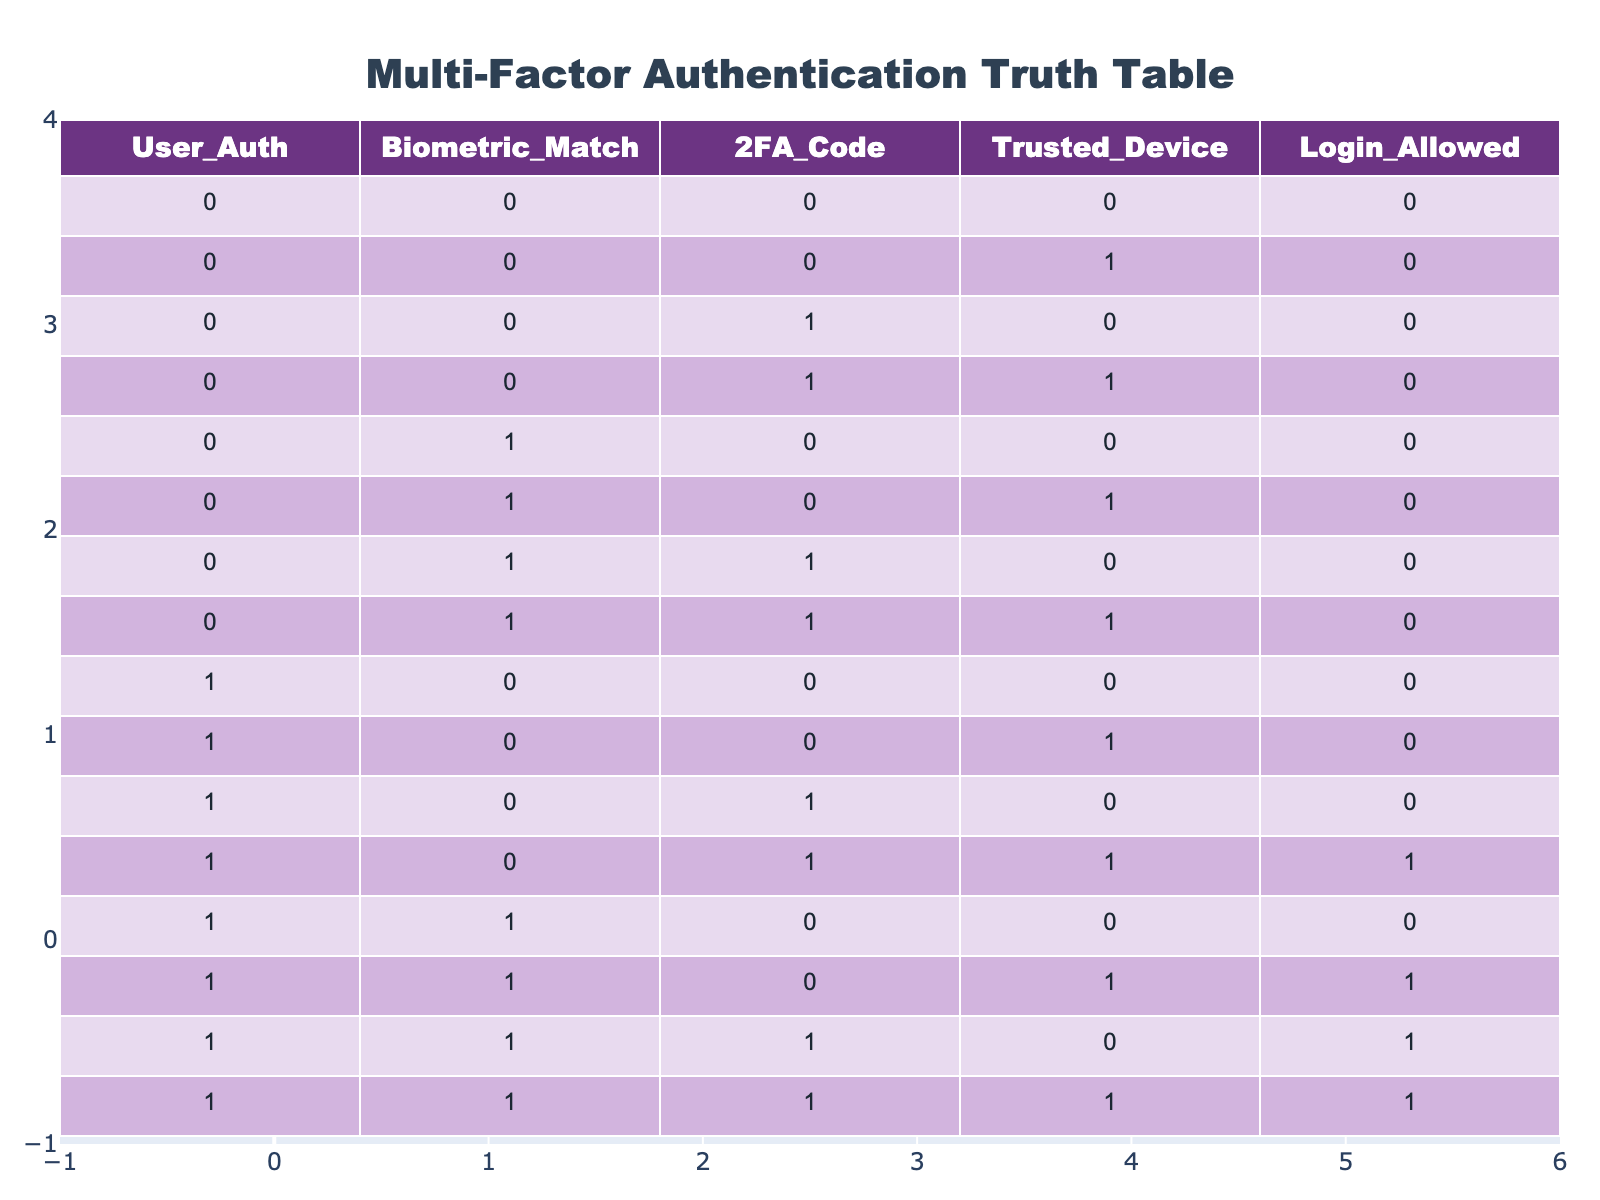What is the maximum number of conditions that can be true for a user to be allowed to log in? To determine the maximum number of true conditions, we examine the row where login is allowed (1). The conditions are: User Auth (1), Biometric Match (1), 2FA Code (1), Trusted Device (1). This row indicates that all four conditions must be true for login to be allowed.
Answer: 4 How many times is the login allowed when the user authentication is true? We look at all rows where User Auth is 1. The login is allowed (1) in three rows: (1, 0, 1, 1), (1, 1, 0, 1), (1, 1, 1, 0), and (1, 1, 1, 1). Thus, the login is permitted four times in total under this condition.
Answer: 4 Is login allowed with Trusted Device being true and User Authentication being false? We check all entries where Trusted Device is 1 and User Auth is 0. The relevant rows (0, 0, 1, 1) show that login is not allowed (0). Thus, it's clear that having a trusted device alone cannot permit login without user authentication.
Answer: No What is the result when all four conditions are true? By referencing the table, when User Auth, Biometric Match, 2FA Code, and Trusted Device are all true, the result for Login Allowed is also true (1). This means that it confirms that all conditions being met grants access.
Answer: Yes How many total combinations of conditions result in login being denied? Up to this point, we find all rows where Login Allowed is 0. Counting these rows provides: (0,0,0,0), (0,0,0,1), (0,0,1,0), (0,0,1,1), (0,1,0,0), (0,1,0,1), (0,1,1,0), (0,1,1,1), (1,0,0,0), (1,0,0,1), (1,0,1,0), (1,1,0,0), this totals to 12 combinations.
Answer: 12 In how many scenarios is login not allowed when the 2FA code is valid? We look at rows with 2FA Code being 1. The rows are (0,0,1,0), (0,0,1,1), (0,1,1,0), (0,1,1,1), (1,0,1,0), (1,0,1,1), (1,1,1,0), and (1,1,1,1). Out of these, login is not allowed in (0,0,1,0), (0,0,1,1), (0,1,1,0), and (1,0,1,0) which gives us a total of 4 scenarios.
Answer: 4 What is the login status if Biometric Match is true and 2FA Code is false? Referencing the table, we find rows where Biometric Match is 1 and 2FA Code is 0, which includes (0,1,0,0), (0,1,0,1), (1,1,0,0), and (1,1,0,1). In all these cases, Login Allowed is 0, indicating login is denied.
Answer: No 